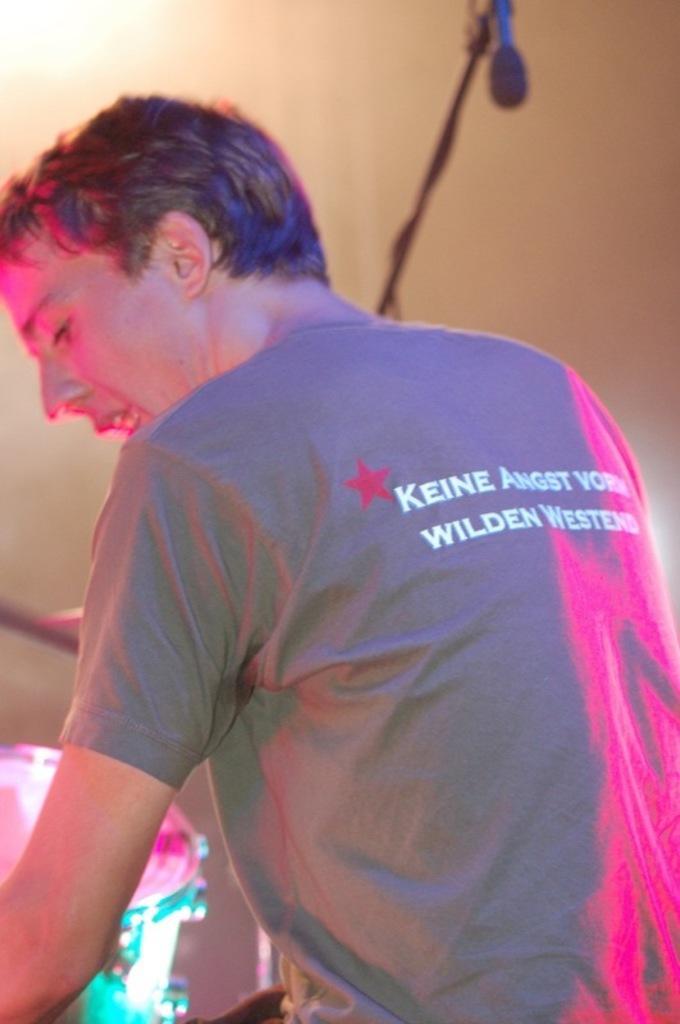Describe this image in one or two sentences. In this image we can see a person. On the left there is a band. In the background there is a wire and we can see an object. There is a wall. 